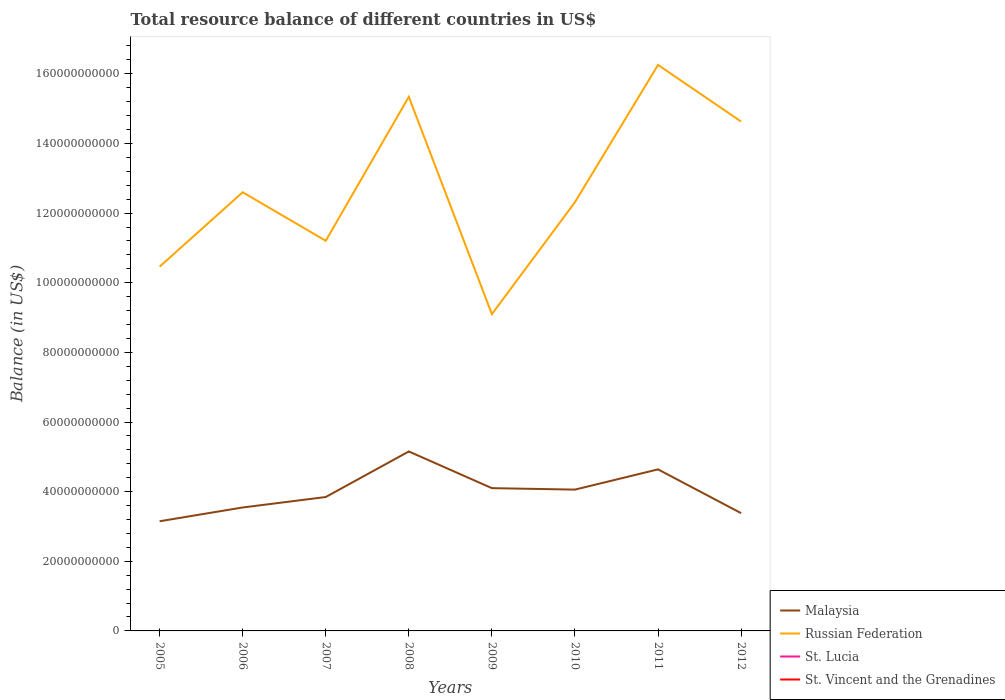Does the line corresponding to Malaysia intersect with the line corresponding to St. Vincent and the Grenadines?
Your answer should be compact. No. Is the number of lines equal to the number of legend labels?
Your answer should be very brief. No. Across all years, what is the maximum total resource balance in Malaysia?
Offer a very short reply. 3.15e+1. What is the total total resource balance in Malaysia in the graph?
Keep it short and to the point. 4.63e+09. What is the difference between the highest and the second highest total resource balance in Russian Federation?
Give a very brief answer. 7.16e+1. What is the difference between the highest and the lowest total resource balance in Russian Federation?
Your answer should be compact. 3. What is the difference between two consecutive major ticks on the Y-axis?
Offer a very short reply. 2.00e+1. Are the values on the major ticks of Y-axis written in scientific E-notation?
Ensure brevity in your answer.  No. Does the graph contain any zero values?
Offer a terse response. Yes. Where does the legend appear in the graph?
Offer a terse response. Bottom right. How are the legend labels stacked?
Your answer should be very brief. Vertical. What is the title of the graph?
Provide a short and direct response. Total resource balance of different countries in US$. What is the label or title of the X-axis?
Keep it short and to the point. Years. What is the label or title of the Y-axis?
Your answer should be compact. Balance (in US$). What is the Balance (in US$) in Malaysia in 2005?
Ensure brevity in your answer.  3.15e+1. What is the Balance (in US$) of Russian Federation in 2005?
Ensure brevity in your answer.  1.05e+11. What is the Balance (in US$) in St. Vincent and the Grenadines in 2005?
Your answer should be compact. 0. What is the Balance (in US$) in Malaysia in 2006?
Offer a very short reply. 3.55e+1. What is the Balance (in US$) of Russian Federation in 2006?
Provide a short and direct response. 1.26e+11. What is the Balance (in US$) of St. Lucia in 2006?
Your answer should be very brief. 0. What is the Balance (in US$) in Malaysia in 2007?
Your answer should be very brief. 3.85e+1. What is the Balance (in US$) of Russian Federation in 2007?
Provide a succinct answer. 1.12e+11. What is the Balance (in US$) of St. Vincent and the Grenadines in 2007?
Ensure brevity in your answer.  0. What is the Balance (in US$) of Malaysia in 2008?
Offer a very short reply. 5.15e+1. What is the Balance (in US$) in Russian Federation in 2008?
Your answer should be very brief. 1.53e+11. What is the Balance (in US$) in St. Lucia in 2008?
Offer a terse response. 0. What is the Balance (in US$) in Malaysia in 2009?
Provide a succinct answer. 4.10e+1. What is the Balance (in US$) of Russian Federation in 2009?
Ensure brevity in your answer.  9.10e+1. What is the Balance (in US$) of St. Lucia in 2009?
Make the answer very short. 0. What is the Balance (in US$) of St. Vincent and the Grenadines in 2009?
Give a very brief answer. 0. What is the Balance (in US$) in Malaysia in 2010?
Provide a succinct answer. 4.06e+1. What is the Balance (in US$) of Russian Federation in 2010?
Give a very brief answer. 1.23e+11. What is the Balance (in US$) of St. Lucia in 2010?
Your answer should be very brief. 0. What is the Balance (in US$) of St. Vincent and the Grenadines in 2010?
Offer a terse response. 0. What is the Balance (in US$) of Malaysia in 2011?
Your response must be concise. 4.64e+1. What is the Balance (in US$) in Russian Federation in 2011?
Ensure brevity in your answer.  1.63e+11. What is the Balance (in US$) in St. Lucia in 2011?
Ensure brevity in your answer.  0. What is the Balance (in US$) in Malaysia in 2012?
Give a very brief answer. 3.38e+1. What is the Balance (in US$) of Russian Federation in 2012?
Provide a succinct answer. 1.46e+11. What is the Balance (in US$) of St. Lucia in 2012?
Offer a very short reply. 0. What is the Balance (in US$) in St. Vincent and the Grenadines in 2012?
Your response must be concise. 0. Across all years, what is the maximum Balance (in US$) of Malaysia?
Keep it short and to the point. 5.15e+1. Across all years, what is the maximum Balance (in US$) of Russian Federation?
Offer a terse response. 1.63e+11. Across all years, what is the minimum Balance (in US$) in Malaysia?
Offer a very short reply. 3.15e+1. Across all years, what is the minimum Balance (in US$) in Russian Federation?
Give a very brief answer. 9.10e+1. What is the total Balance (in US$) in Malaysia in the graph?
Your answer should be compact. 3.19e+11. What is the total Balance (in US$) in Russian Federation in the graph?
Offer a very short reply. 1.02e+12. What is the difference between the Balance (in US$) in Malaysia in 2005 and that in 2006?
Keep it short and to the point. -3.96e+09. What is the difference between the Balance (in US$) in Russian Federation in 2005 and that in 2006?
Your response must be concise. -2.14e+1. What is the difference between the Balance (in US$) in Malaysia in 2005 and that in 2007?
Offer a terse response. -6.96e+09. What is the difference between the Balance (in US$) of Russian Federation in 2005 and that in 2007?
Your response must be concise. -7.44e+09. What is the difference between the Balance (in US$) of Malaysia in 2005 and that in 2008?
Your response must be concise. -2.00e+1. What is the difference between the Balance (in US$) in Russian Federation in 2005 and that in 2008?
Provide a succinct answer. -4.88e+1. What is the difference between the Balance (in US$) in Malaysia in 2005 and that in 2009?
Give a very brief answer. -9.51e+09. What is the difference between the Balance (in US$) of Russian Federation in 2005 and that in 2009?
Give a very brief answer. 1.36e+1. What is the difference between the Balance (in US$) in Malaysia in 2005 and that in 2010?
Give a very brief answer. -9.09e+09. What is the difference between the Balance (in US$) of Russian Federation in 2005 and that in 2010?
Offer a very short reply. -1.85e+1. What is the difference between the Balance (in US$) in Malaysia in 2005 and that in 2011?
Give a very brief answer. -1.49e+1. What is the difference between the Balance (in US$) of Russian Federation in 2005 and that in 2011?
Give a very brief answer. -5.79e+1. What is the difference between the Balance (in US$) in Malaysia in 2005 and that in 2012?
Ensure brevity in your answer.  -2.33e+09. What is the difference between the Balance (in US$) of Russian Federation in 2005 and that in 2012?
Your response must be concise. -4.17e+1. What is the difference between the Balance (in US$) of Malaysia in 2006 and that in 2007?
Provide a short and direct response. -3.00e+09. What is the difference between the Balance (in US$) of Russian Federation in 2006 and that in 2007?
Offer a terse response. 1.39e+1. What is the difference between the Balance (in US$) in Malaysia in 2006 and that in 2008?
Ensure brevity in your answer.  -1.61e+1. What is the difference between the Balance (in US$) in Russian Federation in 2006 and that in 2008?
Provide a succinct answer. -2.74e+1. What is the difference between the Balance (in US$) in Malaysia in 2006 and that in 2009?
Your answer should be compact. -5.55e+09. What is the difference between the Balance (in US$) in Russian Federation in 2006 and that in 2009?
Your response must be concise. 3.50e+1. What is the difference between the Balance (in US$) in Malaysia in 2006 and that in 2010?
Ensure brevity in your answer.  -5.13e+09. What is the difference between the Balance (in US$) in Russian Federation in 2006 and that in 2010?
Make the answer very short. 2.85e+09. What is the difference between the Balance (in US$) of Malaysia in 2006 and that in 2011?
Your response must be concise. -1.09e+1. What is the difference between the Balance (in US$) in Russian Federation in 2006 and that in 2011?
Make the answer very short. -3.66e+1. What is the difference between the Balance (in US$) in Malaysia in 2006 and that in 2012?
Ensure brevity in your answer.  1.63e+09. What is the difference between the Balance (in US$) in Russian Federation in 2006 and that in 2012?
Ensure brevity in your answer.  -2.03e+1. What is the difference between the Balance (in US$) of Malaysia in 2007 and that in 2008?
Provide a short and direct response. -1.31e+1. What is the difference between the Balance (in US$) of Russian Federation in 2007 and that in 2008?
Provide a succinct answer. -4.13e+1. What is the difference between the Balance (in US$) of Malaysia in 2007 and that in 2009?
Your answer should be very brief. -2.55e+09. What is the difference between the Balance (in US$) in Russian Federation in 2007 and that in 2009?
Your response must be concise. 2.11e+1. What is the difference between the Balance (in US$) in Malaysia in 2007 and that in 2010?
Make the answer very short. -2.13e+09. What is the difference between the Balance (in US$) in Russian Federation in 2007 and that in 2010?
Give a very brief answer. -1.11e+1. What is the difference between the Balance (in US$) in Malaysia in 2007 and that in 2011?
Provide a succinct answer. -7.94e+09. What is the difference between the Balance (in US$) of Russian Federation in 2007 and that in 2011?
Your response must be concise. -5.05e+1. What is the difference between the Balance (in US$) in Malaysia in 2007 and that in 2012?
Provide a short and direct response. 4.63e+09. What is the difference between the Balance (in US$) in Russian Federation in 2007 and that in 2012?
Your answer should be very brief. -3.42e+1. What is the difference between the Balance (in US$) of Malaysia in 2008 and that in 2009?
Give a very brief answer. 1.05e+1. What is the difference between the Balance (in US$) in Russian Federation in 2008 and that in 2009?
Provide a succinct answer. 6.24e+1. What is the difference between the Balance (in US$) in Malaysia in 2008 and that in 2010?
Your answer should be compact. 1.10e+1. What is the difference between the Balance (in US$) of Russian Federation in 2008 and that in 2010?
Keep it short and to the point. 3.03e+1. What is the difference between the Balance (in US$) of Malaysia in 2008 and that in 2011?
Your answer should be compact. 5.14e+09. What is the difference between the Balance (in US$) in Russian Federation in 2008 and that in 2011?
Offer a very short reply. -9.16e+09. What is the difference between the Balance (in US$) of Malaysia in 2008 and that in 2012?
Provide a short and direct response. 1.77e+1. What is the difference between the Balance (in US$) of Russian Federation in 2008 and that in 2012?
Ensure brevity in your answer.  7.10e+09. What is the difference between the Balance (in US$) in Malaysia in 2009 and that in 2010?
Provide a succinct answer. 4.19e+08. What is the difference between the Balance (in US$) of Russian Federation in 2009 and that in 2010?
Offer a terse response. -3.22e+1. What is the difference between the Balance (in US$) of Malaysia in 2009 and that in 2011?
Your response must be concise. -5.39e+09. What is the difference between the Balance (in US$) in Russian Federation in 2009 and that in 2011?
Your answer should be very brief. -7.16e+1. What is the difference between the Balance (in US$) in Malaysia in 2009 and that in 2012?
Your response must be concise. 7.18e+09. What is the difference between the Balance (in US$) in Russian Federation in 2009 and that in 2012?
Provide a succinct answer. -5.53e+1. What is the difference between the Balance (in US$) of Malaysia in 2010 and that in 2011?
Your response must be concise. -5.81e+09. What is the difference between the Balance (in US$) in Russian Federation in 2010 and that in 2011?
Provide a short and direct response. -3.94e+1. What is the difference between the Balance (in US$) in Malaysia in 2010 and that in 2012?
Offer a terse response. 6.76e+09. What is the difference between the Balance (in US$) of Russian Federation in 2010 and that in 2012?
Your answer should be very brief. -2.32e+1. What is the difference between the Balance (in US$) in Malaysia in 2011 and that in 2012?
Keep it short and to the point. 1.26e+1. What is the difference between the Balance (in US$) of Russian Federation in 2011 and that in 2012?
Make the answer very short. 1.63e+1. What is the difference between the Balance (in US$) of Malaysia in 2005 and the Balance (in US$) of Russian Federation in 2006?
Your answer should be very brief. -9.45e+1. What is the difference between the Balance (in US$) in Malaysia in 2005 and the Balance (in US$) in Russian Federation in 2007?
Offer a terse response. -8.06e+1. What is the difference between the Balance (in US$) of Malaysia in 2005 and the Balance (in US$) of Russian Federation in 2008?
Your answer should be very brief. -1.22e+11. What is the difference between the Balance (in US$) in Malaysia in 2005 and the Balance (in US$) in Russian Federation in 2009?
Offer a very short reply. -5.95e+1. What is the difference between the Balance (in US$) of Malaysia in 2005 and the Balance (in US$) of Russian Federation in 2010?
Provide a short and direct response. -9.17e+1. What is the difference between the Balance (in US$) of Malaysia in 2005 and the Balance (in US$) of Russian Federation in 2011?
Your response must be concise. -1.31e+11. What is the difference between the Balance (in US$) of Malaysia in 2005 and the Balance (in US$) of Russian Federation in 2012?
Keep it short and to the point. -1.15e+11. What is the difference between the Balance (in US$) in Malaysia in 2006 and the Balance (in US$) in Russian Federation in 2007?
Your answer should be very brief. -7.66e+1. What is the difference between the Balance (in US$) of Malaysia in 2006 and the Balance (in US$) of Russian Federation in 2008?
Keep it short and to the point. -1.18e+11. What is the difference between the Balance (in US$) in Malaysia in 2006 and the Balance (in US$) in Russian Federation in 2009?
Ensure brevity in your answer.  -5.55e+1. What is the difference between the Balance (in US$) in Malaysia in 2006 and the Balance (in US$) in Russian Federation in 2010?
Your answer should be compact. -8.77e+1. What is the difference between the Balance (in US$) in Malaysia in 2006 and the Balance (in US$) in Russian Federation in 2011?
Your response must be concise. -1.27e+11. What is the difference between the Balance (in US$) in Malaysia in 2006 and the Balance (in US$) in Russian Federation in 2012?
Offer a terse response. -1.11e+11. What is the difference between the Balance (in US$) of Malaysia in 2007 and the Balance (in US$) of Russian Federation in 2008?
Provide a succinct answer. -1.15e+11. What is the difference between the Balance (in US$) of Malaysia in 2007 and the Balance (in US$) of Russian Federation in 2009?
Keep it short and to the point. -5.25e+1. What is the difference between the Balance (in US$) of Malaysia in 2007 and the Balance (in US$) of Russian Federation in 2010?
Your answer should be very brief. -8.47e+1. What is the difference between the Balance (in US$) of Malaysia in 2007 and the Balance (in US$) of Russian Federation in 2011?
Offer a terse response. -1.24e+11. What is the difference between the Balance (in US$) of Malaysia in 2007 and the Balance (in US$) of Russian Federation in 2012?
Your response must be concise. -1.08e+11. What is the difference between the Balance (in US$) of Malaysia in 2008 and the Balance (in US$) of Russian Federation in 2009?
Offer a terse response. -3.94e+1. What is the difference between the Balance (in US$) of Malaysia in 2008 and the Balance (in US$) of Russian Federation in 2010?
Your answer should be very brief. -7.16e+1. What is the difference between the Balance (in US$) in Malaysia in 2008 and the Balance (in US$) in Russian Federation in 2011?
Provide a succinct answer. -1.11e+11. What is the difference between the Balance (in US$) of Malaysia in 2008 and the Balance (in US$) of Russian Federation in 2012?
Your answer should be compact. -9.48e+1. What is the difference between the Balance (in US$) in Malaysia in 2009 and the Balance (in US$) in Russian Federation in 2010?
Offer a terse response. -8.21e+1. What is the difference between the Balance (in US$) in Malaysia in 2009 and the Balance (in US$) in Russian Federation in 2011?
Make the answer very short. -1.22e+11. What is the difference between the Balance (in US$) in Malaysia in 2009 and the Balance (in US$) in Russian Federation in 2012?
Offer a very short reply. -1.05e+11. What is the difference between the Balance (in US$) in Malaysia in 2010 and the Balance (in US$) in Russian Federation in 2011?
Give a very brief answer. -1.22e+11. What is the difference between the Balance (in US$) of Malaysia in 2010 and the Balance (in US$) of Russian Federation in 2012?
Offer a very short reply. -1.06e+11. What is the difference between the Balance (in US$) in Malaysia in 2011 and the Balance (in US$) in Russian Federation in 2012?
Your response must be concise. -9.99e+1. What is the average Balance (in US$) in Malaysia per year?
Your answer should be compact. 3.98e+1. What is the average Balance (in US$) of Russian Federation per year?
Provide a succinct answer. 1.27e+11. What is the average Balance (in US$) of St. Vincent and the Grenadines per year?
Your answer should be very brief. 0. In the year 2005, what is the difference between the Balance (in US$) of Malaysia and Balance (in US$) of Russian Federation?
Your answer should be very brief. -7.31e+1. In the year 2006, what is the difference between the Balance (in US$) of Malaysia and Balance (in US$) of Russian Federation?
Give a very brief answer. -9.05e+1. In the year 2007, what is the difference between the Balance (in US$) of Malaysia and Balance (in US$) of Russian Federation?
Your answer should be compact. -7.36e+1. In the year 2008, what is the difference between the Balance (in US$) in Malaysia and Balance (in US$) in Russian Federation?
Keep it short and to the point. -1.02e+11. In the year 2009, what is the difference between the Balance (in US$) in Malaysia and Balance (in US$) in Russian Federation?
Provide a succinct answer. -5.00e+1. In the year 2010, what is the difference between the Balance (in US$) of Malaysia and Balance (in US$) of Russian Federation?
Provide a short and direct response. -8.26e+1. In the year 2011, what is the difference between the Balance (in US$) of Malaysia and Balance (in US$) of Russian Federation?
Provide a succinct answer. -1.16e+11. In the year 2012, what is the difference between the Balance (in US$) in Malaysia and Balance (in US$) in Russian Federation?
Offer a terse response. -1.12e+11. What is the ratio of the Balance (in US$) of Malaysia in 2005 to that in 2006?
Keep it short and to the point. 0.89. What is the ratio of the Balance (in US$) in Russian Federation in 2005 to that in 2006?
Ensure brevity in your answer.  0.83. What is the ratio of the Balance (in US$) of Malaysia in 2005 to that in 2007?
Your answer should be compact. 0.82. What is the ratio of the Balance (in US$) of Russian Federation in 2005 to that in 2007?
Keep it short and to the point. 0.93. What is the ratio of the Balance (in US$) of Malaysia in 2005 to that in 2008?
Keep it short and to the point. 0.61. What is the ratio of the Balance (in US$) in Russian Federation in 2005 to that in 2008?
Provide a succinct answer. 0.68. What is the ratio of the Balance (in US$) in Malaysia in 2005 to that in 2009?
Provide a succinct answer. 0.77. What is the ratio of the Balance (in US$) in Russian Federation in 2005 to that in 2009?
Your answer should be very brief. 1.15. What is the ratio of the Balance (in US$) in Malaysia in 2005 to that in 2010?
Your answer should be very brief. 0.78. What is the ratio of the Balance (in US$) of Russian Federation in 2005 to that in 2010?
Your answer should be very brief. 0.85. What is the ratio of the Balance (in US$) of Malaysia in 2005 to that in 2011?
Your response must be concise. 0.68. What is the ratio of the Balance (in US$) in Russian Federation in 2005 to that in 2011?
Offer a terse response. 0.64. What is the ratio of the Balance (in US$) in Malaysia in 2005 to that in 2012?
Provide a short and direct response. 0.93. What is the ratio of the Balance (in US$) in Russian Federation in 2005 to that in 2012?
Provide a short and direct response. 0.71. What is the ratio of the Balance (in US$) of Malaysia in 2006 to that in 2007?
Provide a short and direct response. 0.92. What is the ratio of the Balance (in US$) of Russian Federation in 2006 to that in 2007?
Make the answer very short. 1.12. What is the ratio of the Balance (in US$) in Malaysia in 2006 to that in 2008?
Provide a short and direct response. 0.69. What is the ratio of the Balance (in US$) of Russian Federation in 2006 to that in 2008?
Offer a very short reply. 0.82. What is the ratio of the Balance (in US$) of Malaysia in 2006 to that in 2009?
Offer a very short reply. 0.86. What is the ratio of the Balance (in US$) of Russian Federation in 2006 to that in 2009?
Make the answer very short. 1.38. What is the ratio of the Balance (in US$) in Malaysia in 2006 to that in 2010?
Offer a very short reply. 0.87. What is the ratio of the Balance (in US$) in Russian Federation in 2006 to that in 2010?
Your response must be concise. 1.02. What is the ratio of the Balance (in US$) of Malaysia in 2006 to that in 2011?
Ensure brevity in your answer.  0.76. What is the ratio of the Balance (in US$) of Russian Federation in 2006 to that in 2011?
Offer a terse response. 0.78. What is the ratio of the Balance (in US$) of Malaysia in 2006 to that in 2012?
Give a very brief answer. 1.05. What is the ratio of the Balance (in US$) in Russian Federation in 2006 to that in 2012?
Offer a terse response. 0.86. What is the ratio of the Balance (in US$) in Malaysia in 2007 to that in 2008?
Provide a short and direct response. 0.75. What is the ratio of the Balance (in US$) in Russian Federation in 2007 to that in 2008?
Offer a very short reply. 0.73. What is the ratio of the Balance (in US$) in Malaysia in 2007 to that in 2009?
Your response must be concise. 0.94. What is the ratio of the Balance (in US$) in Russian Federation in 2007 to that in 2009?
Your response must be concise. 1.23. What is the ratio of the Balance (in US$) of Malaysia in 2007 to that in 2010?
Provide a succinct answer. 0.95. What is the ratio of the Balance (in US$) of Russian Federation in 2007 to that in 2010?
Provide a short and direct response. 0.91. What is the ratio of the Balance (in US$) of Malaysia in 2007 to that in 2011?
Your response must be concise. 0.83. What is the ratio of the Balance (in US$) of Russian Federation in 2007 to that in 2011?
Your answer should be very brief. 0.69. What is the ratio of the Balance (in US$) in Malaysia in 2007 to that in 2012?
Offer a terse response. 1.14. What is the ratio of the Balance (in US$) in Russian Federation in 2007 to that in 2012?
Your response must be concise. 0.77. What is the ratio of the Balance (in US$) of Malaysia in 2008 to that in 2009?
Your answer should be compact. 1.26. What is the ratio of the Balance (in US$) of Russian Federation in 2008 to that in 2009?
Make the answer very short. 1.69. What is the ratio of the Balance (in US$) of Malaysia in 2008 to that in 2010?
Ensure brevity in your answer.  1.27. What is the ratio of the Balance (in US$) in Russian Federation in 2008 to that in 2010?
Your response must be concise. 1.25. What is the ratio of the Balance (in US$) of Malaysia in 2008 to that in 2011?
Provide a succinct answer. 1.11. What is the ratio of the Balance (in US$) of Russian Federation in 2008 to that in 2011?
Your answer should be compact. 0.94. What is the ratio of the Balance (in US$) in Malaysia in 2008 to that in 2012?
Provide a succinct answer. 1.52. What is the ratio of the Balance (in US$) of Russian Federation in 2008 to that in 2012?
Ensure brevity in your answer.  1.05. What is the ratio of the Balance (in US$) of Malaysia in 2009 to that in 2010?
Your answer should be very brief. 1.01. What is the ratio of the Balance (in US$) of Russian Federation in 2009 to that in 2010?
Your answer should be compact. 0.74. What is the ratio of the Balance (in US$) in Malaysia in 2009 to that in 2011?
Offer a terse response. 0.88. What is the ratio of the Balance (in US$) in Russian Federation in 2009 to that in 2011?
Your answer should be very brief. 0.56. What is the ratio of the Balance (in US$) in Malaysia in 2009 to that in 2012?
Provide a short and direct response. 1.21. What is the ratio of the Balance (in US$) of Russian Federation in 2009 to that in 2012?
Provide a short and direct response. 0.62. What is the ratio of the Balance (in US$) of Malaysia in 2010 to that in 2011?
Your answer should be very brief. 0.87. What is the ratio of the Balance (in US$) in Russian Federation in 2010 to that in 2011?
Provide a succinct answer. 0.76. What is the ratio of the Balance (in US$) in Malaysia in 2010 to that in 2012?
Provide a short and direct response. 1.2. What is the ratio of the Balance (in US$) of Russian Federation in 2010 to that in 2012?
Provide a succinct answer. 0.84. What is the ratio of the Balance (in US$) in Malaysia in 2011 to that in 2012?
Make the answer very short. 1.37. What is the difference between the highest and the second highest Balance (in US$) of Malaysia?
Offer a terse response. 5.14e+09. What is the difference between the highest and the second highest Balance (in US$) of Russian Federation?
Offer a terse response. 9.16e+09. What is the difference between the highest and the lowest Balance (in US$) in Malaysia?
Your answer should be compact. 2.00e+1. What is the difference between the highest and the lowest Balance (in US$) in Russian Federation?
Your response must be concise. 7.16e+1. 